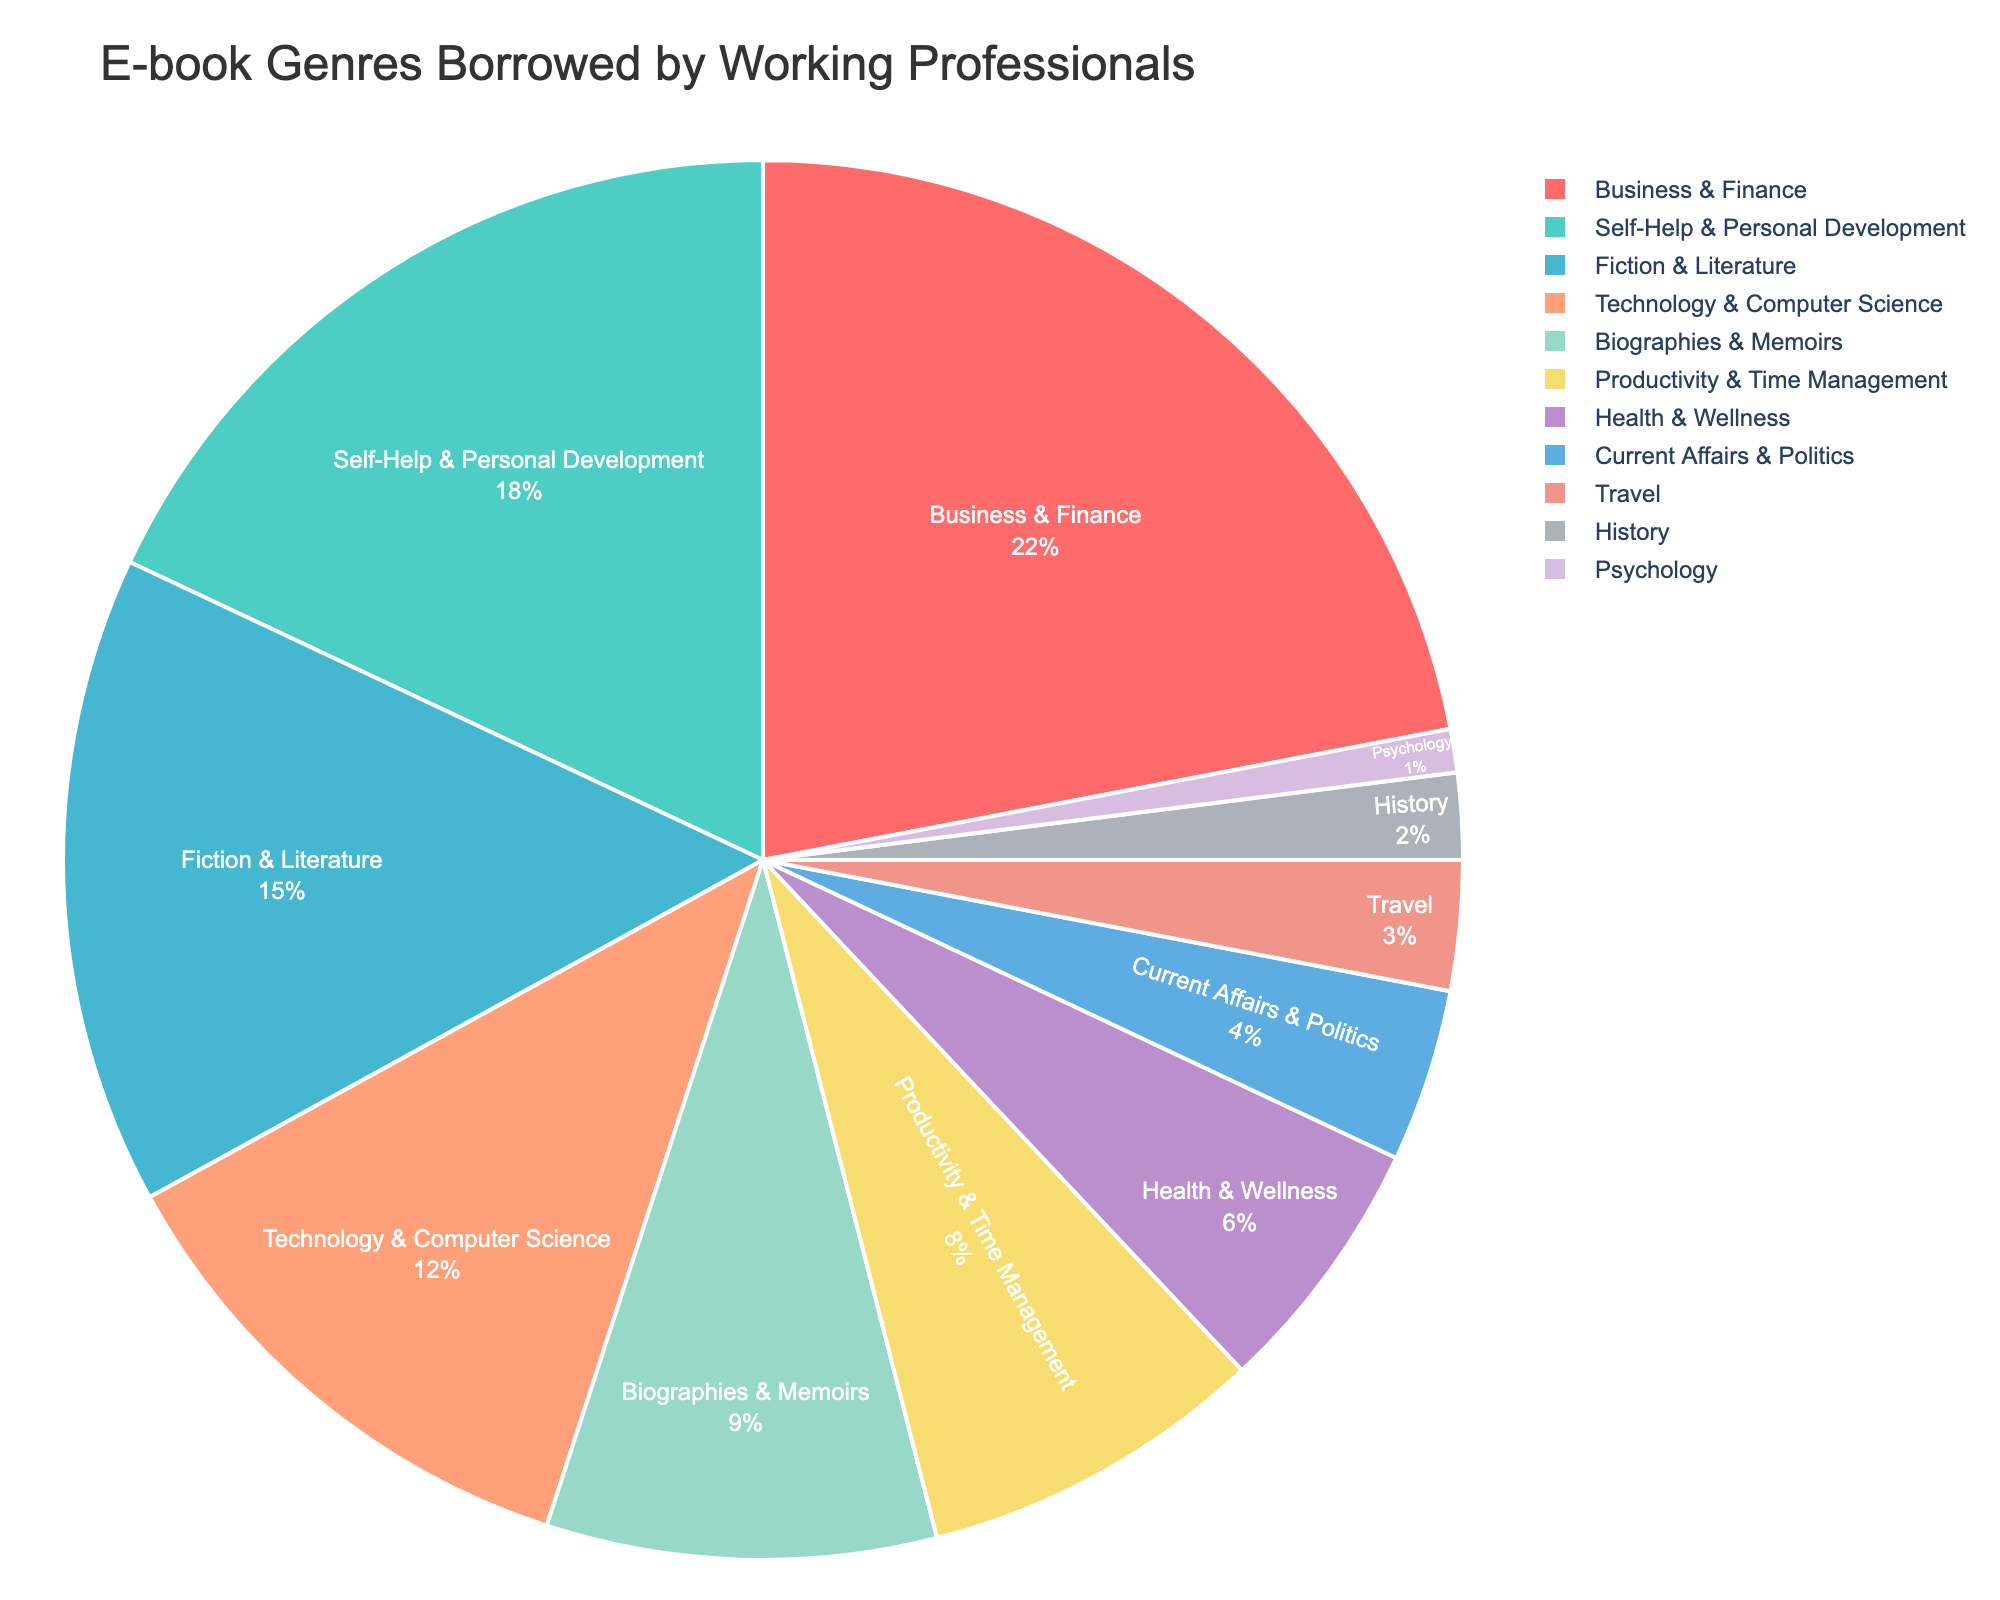What's the most borrowed e-book genre by working professionals? The pie chart indicates that the genre with the largest segment is Business & Finance, which takes up 22% of the chart.
Answer: Business & Finance Which genre is borrowed less, Travel or History? The segment for Travel is 3%, while the segment for History is 2%. Since 3% is greater than 2%, History is borrowed less than Travel.
Answer: History What is the combined percentage of all non-fiction genres (Business & Finance, Self-Help & Personal Development, Technology & Computer Science, Biographies & Memoirs, Productivity & Time Management, Health & Wellness, Current Affairs & Politics, Travel, History, Psychology)? Adding up all the individual percentages: 22% (Business & Finance) + 18% (Self-Help & Personal Development) + 12% (Technology & Computer Science) + 9% (Biographies & Memoirs) + 8% (Productivity & Time Management) + 6% (Health & Wellness) + 4% (Current Affairs & Politics) + 3% (Travel) + 2% (History) + 1% (Psychology) gives 85%.
Answer: 85% How much more popular is Self-Help & Personal Development compared to Current Affairs & Politics? Self-Help & Personal Development accounts for 18% while Current Affairs & Politics account for 4%. The difference is 18% - 4% = 14%.
Answer: 14% Which genre has the smallest share, and what is its percentage? The smallest segment in the pie chart represents Psychology, which has a share of 1%.
Answer: Psychology, 1% How does the percentage of Biographies & Memoirs compare to Fiction & Literature? The pie chart shows that Fiction & Literature make up 15% of the chart, and Biographies & Memoirs make up 9%. Comparing these, Fiction & Literature have a higher percentage than Biographies & Memoirs.
Answer: Fiction & Literature have a higher percentage What are the two least borrowed genres and their combined percentage? The least borrowed genres are History and Psychology, with percentages of 2% and 1% respectively. Their combined percentage is 2% + 1% = 3%.
Answer: History and Psychology, 3% Which genre category falls in the middle range (10% - 20%)? The genres with percentages of 10% - 20% are Self-Help & Personal Development (18%) and Technology & Computer Science (12%).
Answer: Self-Help & Personal Development, Technology & Computer Science 